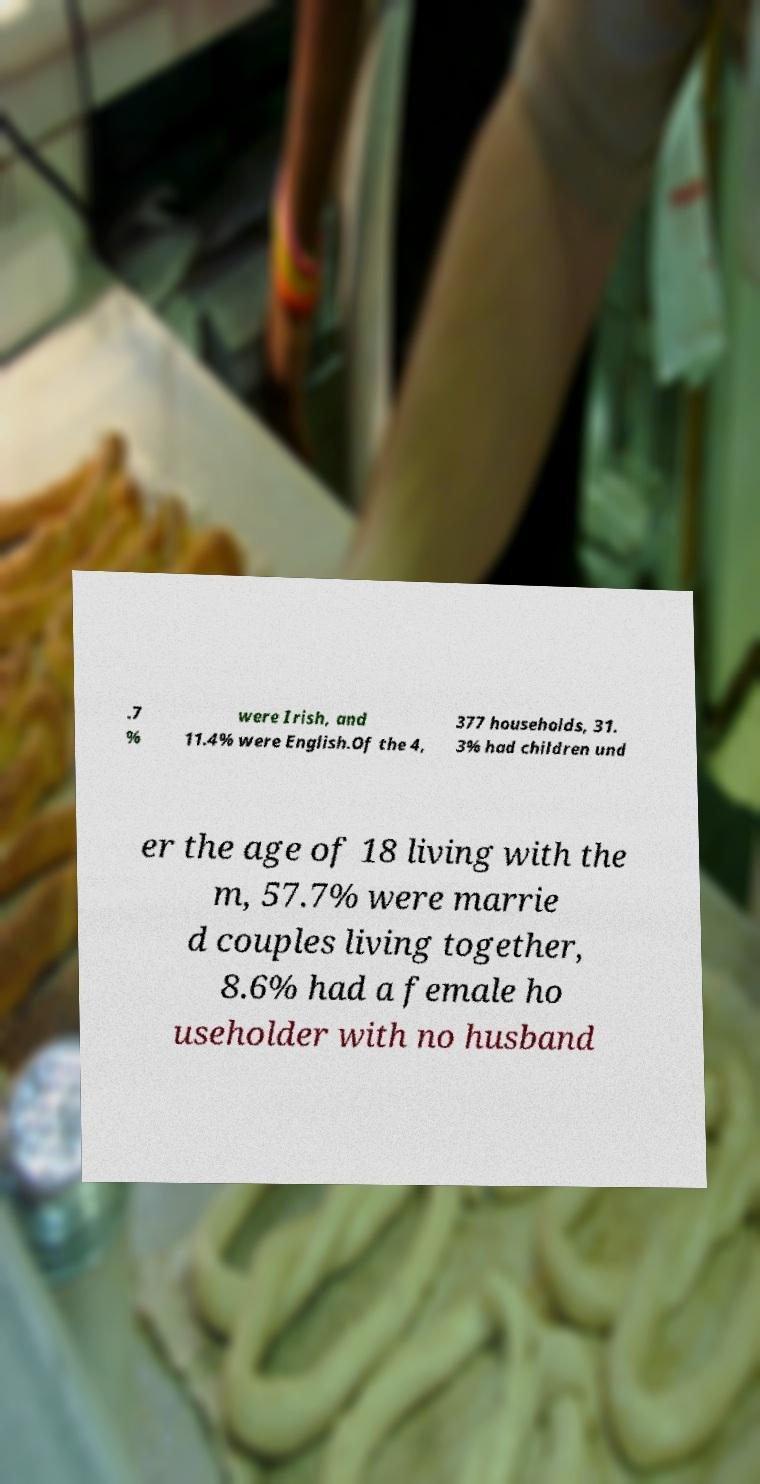I need the written content from this picture converted into text. Can you do that? .7 % were Irish, and 11.4% were English.Of the 4, 377 households, 31. 3% had children und er the age of 18 living with the m, 57.7% were marrie d couples living together, 8.6% had a female ho useholder with no husband 